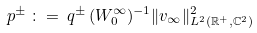<formula> <loc_0><loc_0><loc_500><loc_500>p ^ { \pm } \, \colon = \, q ^ { \pm } \, ( W _ { 0 } ^ { \infty } ) ^ { - 1 } \| v _ { \infty } \| _ { L ^ { 2 } ( \mathbb { R } ^ { + } , \mathbb { C } ^ { 2 } ) } ^ { 2 }</formula> 